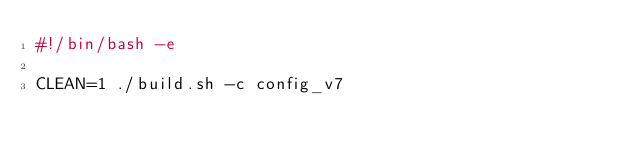<code> <loc_0><loc_0><loc_500><loc_500><_Bash_>#!/bin/bash -e

CLEAN=1 ./build.sh -c config_v7
</code> 